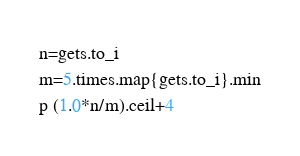Convert code to text. <code><loc_0><loc_0><loc_500><loc_500><_Ruby_>n=gets.to_i
m=5.times.map{gets.to_i}.min
p (1.0*n/m).ceil+4</code> 